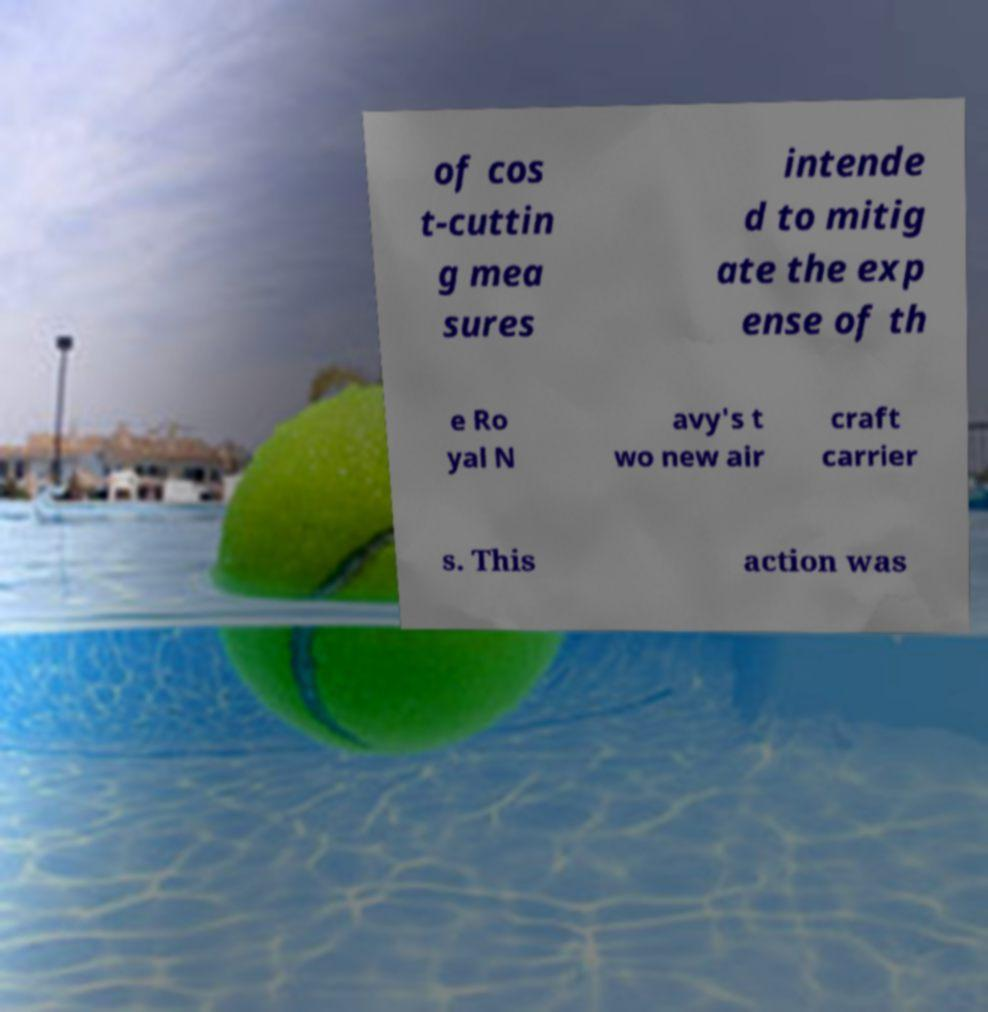Please read and relay the text visible in this image. What does it say? of cos t-cuttin g mea sures intende d to mitig ate the exp ense of th e Ro yal N avy's t wo new air craft carrier s. This action was 